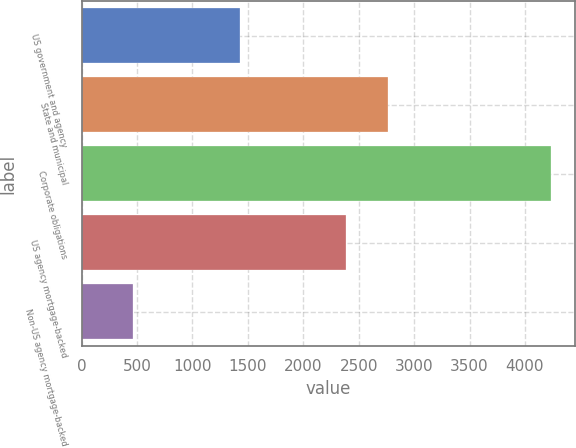<chart> <loc_0><loc_0><loc_500><loc_500><bar_chart><fcel>US government and agency<fcel>State and municipal<fcel>Corporate obligations<fcel>US agency mortgage-backed<fcel>Non-US agency mortgage-backed<nl><fcel>1425<fcel>2766<fcel>4239<fcel>2388<fcel>459<nl></chart> 